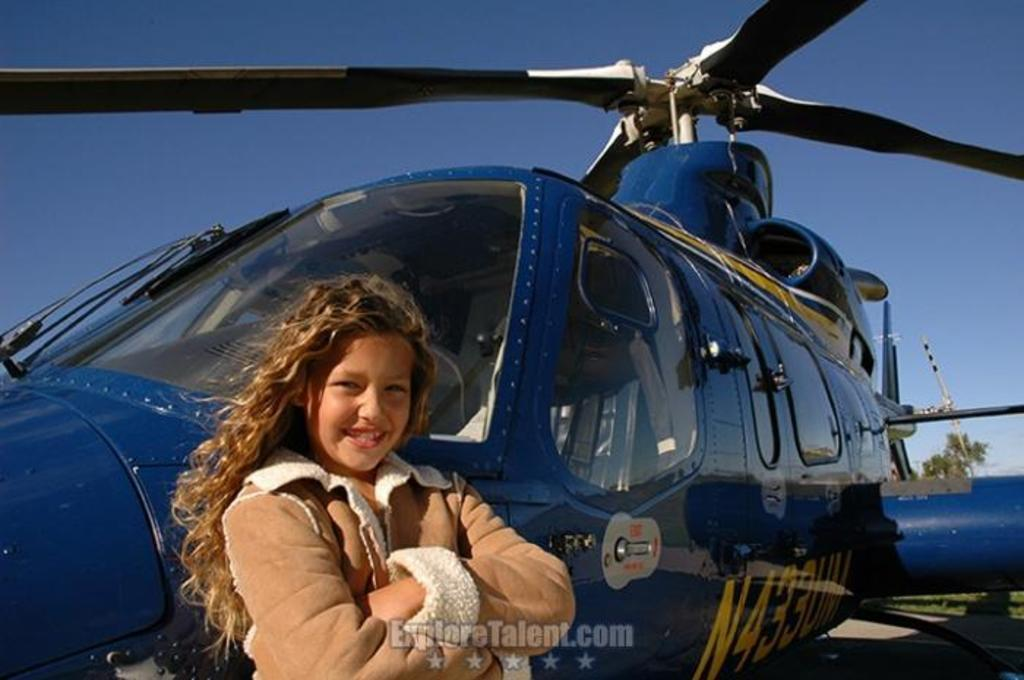<image>
Summarize the visual content of the image. ExploreTalent.com shows a picture of a girl in front of a blue helicopter. 